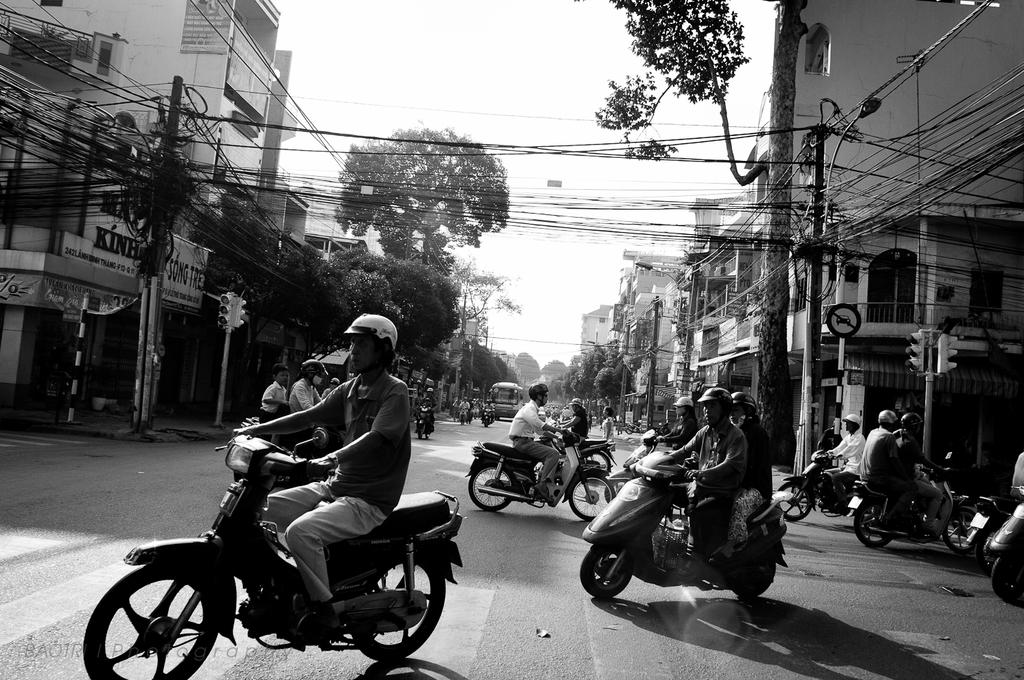What are the people in the image doing? The people in the image are riding bikes on a road. What other vehicles are present on the road? There is a bus on the road. What can be seen on the other side of the road? There are buildings and trees on the other side of the road. What is the opinion of the crate about the bikers in the image? There is no crate present in the image, so it cannot have an opinion about the bikers. 